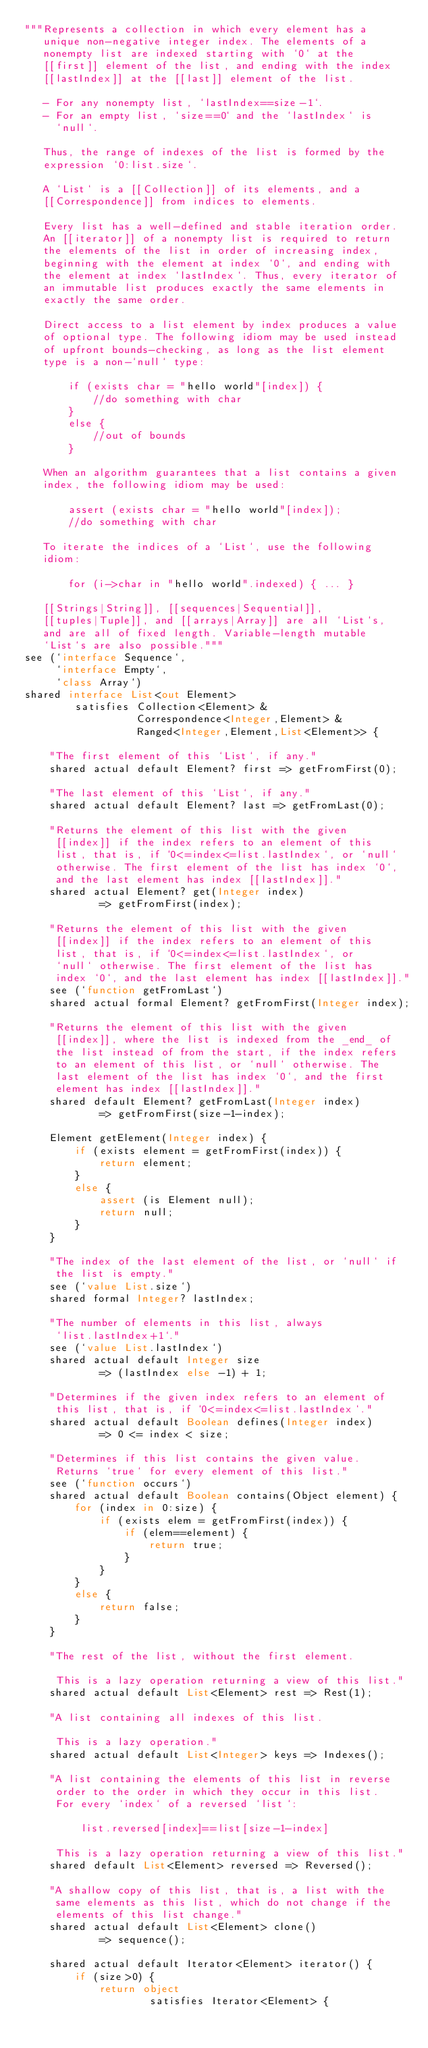Convert code to text. <code><loc_0><loc_0><loc_500><loc_500><_Ceylon_>"""Represents a collection in which every element has a 
   unique non-negative integer index. The elements of a
   nonempty list are indexed starting with `0` at the 
   [[first]] element of the list, and ending with the index
   [[lastIndex]] at the [[last]] element of the list.
   
   - For any nonempty list, `lastIndex==size-1`. 
   - For an empty list, `size==0` and the `lastIndex` is 
     `null`.
   
   Thus, the range of indexes of the list is formed by the 
   expression `0:list.size`.
   
   A `List` is a [[Collection]] of its elements, and a 
   [[Correspondence]] from indices to elements.
   
   Every list has a well-defined and stable iteration order.
   An [[iterator]] of a nonempty list is required to return 
   the elements of the list in order of increasing index, 
   beginning with the element at index `0`, and ending with
   the element at index `lastIndex`. Thus, every iterator of 
   an immutable list produces exactly the same elements in 
   exactly the same order.
   
   Direct access to a list element by index produces a value 
   of optional type. The following idiom may be used instead 
   of upfront bounds-checking, as long as the list element 
   type is a non-`null` type:
   
       if (exists char = "hello world"[index]) { 
           //do something with char
       }
       else {
           //out of bounds
       }
   
   When an algorithm guarantees that a list contains a given 
   index, the following idiom may be used:
   
       assert (exists char = "hello world"[index]);
       //do something with char
   
   To iterate the indices of a `List`, use the following
   idiom:
   
       for (i->char in "hello world".indexed) { ... }
   
   [[Strings|String]], [[sequences|Sequential]], 
   [[tuples|Tuple]], and [[arrays|Array]] are all `List`s,
   and are all of fixed length. Variable-length mutable
   `List`s are also possible."""
see (`interface Sequence`, 
     `interface Empty`, 
     `class Array`)
shared interface List<out Element>
        satisfies Collection<Element> &
                  Correspondence<Integer,Element> &
                  Ranged<Integer,Element,List<Element>> {
    
    "The first element of this `List`, if any."
    shared actual default Element? first => getFromFirst(0);
    
    "The last element of this `List`, if any."
    shared actual default Element? last => getFromLast(0);
    
    "Returns the element of this list with the given 
     [[index]] if the index refers to an element of this
     list, that is, if `0<=index<=list.lastIndex`, or `null` 
     otherwise. The first element of the list has index `0`,
     and the last element has index [[lastIndex]]."
    shared actual Element? get(Integer index) 
            => getFromFirst(index);
    
    "Returns the element of this list with the given 
     [[index]] if the index refers to an element of this
     list, that is, if `0<=index<=list.lastIndex`, or 
     `null` otherwise. The first element of the list has 
     index `0`, and the last element has index [[lastIndex]]."
    see (`function getFromLast`)
    shared actual formal Element? getFromFirst(Integer index);
    
    "Returns the element of this list with the given 
     [[index]], where the list is indexed from the _end_ of 
     the list instead of from the start, if the index refers
     to an element of this list, or `null` otherwise. The
     last element of the list has index `0`, and the first
     element has index [[lastIndex]]."
    shared default Element? getFromLast(Integer index)
            => getFromFirst(size-1-index);
    
    Element getElement(Integer index) {
        if (exists element = getFromFirst(index)) { 
            return element;
        }
        else {
            assert (is Element null);
            return null; 
        }
    }
    
    "The index of the last element of the list, or `null` if 
     the list is empty."
    see (`value List.size`)
    shared formal Integer? lastIndex;
    
    "The number of elements in this list, always
     `list.lastIndex+1`."
    see (`value List.lastIndex`)
    shared actual default Integer size 
            => (lastIndex else -1) + 1;
    
    "Determines if the given index refers to an element of 
     this list, that is, if `0<=index<=list.lastIndex`."
    shared actual default Boolean defines(Integer index) 
            => 0 <= index < size;
    
    "Determines if this list contains the given value.
     Returns `true` for every element of this list."
    see (`function occurs`)
    shared actual default Boolean contains(Object element) {
        for (index in 0:size) {
            if (exists elem = getFromFirst(index)) {
                if (elem==element) {
                    return true;
                }
            }
        }
        else {
            return false;
        }
    }
    
    "The rest of the list, without the first element.
     
     This is a lazy operation returning a view of this list."
    shared actual default List<Element> rest => Rest(1);
    
    "A list containing all indexes of this list.
     
     This is a lazy operation."
    shared actual default List<Integer> keys => Indexes();
    
    "A list containing the elements of this list in reverse 
     order to the order in which they occur in this list. 
     For every `index` of a reversed `list`:
     
         list.reversed[index]==list[size-1-index]
     
     This is a lazy operation returning a view of this list."
    shared default List<Element> reversed => Reversed();
    
    "A shallow copy of this list, that is, a list with the
     same elements as this list, which do not change if the
     elements of this list change."
    shared actual default List<Element> clone() 
            => sequence();
    
    shared actual default Iterator<Element> iterator() {
        if (size>0) {
            return object
                    satisfies Iterator<Element> {</code> 